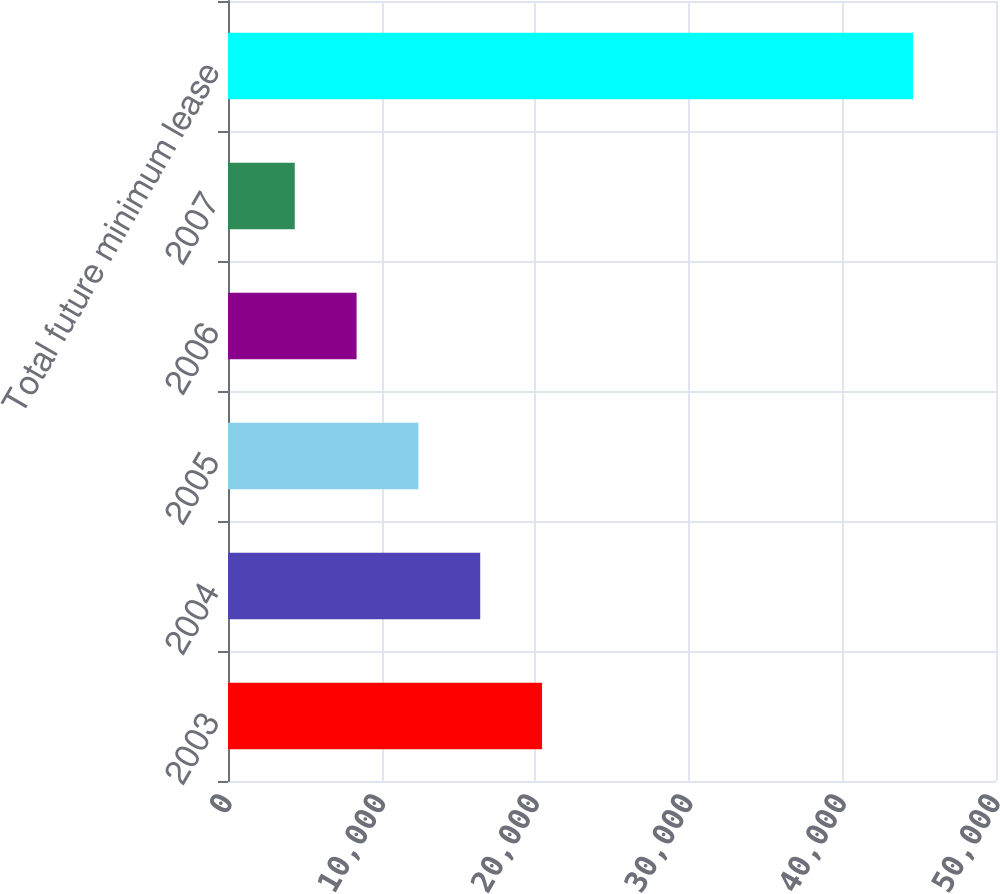Convert chart. <chart><loc_0><loc_0><loc_500><loc_500><bar_chart><fcel>2003<fcel>2004<fcel>2005<fcel>2006<fcel>2007<fcel>Total future minimum lease<nl><fcel>20446<fcel>16421<fcel>12396<fcel>8371<fcel>4346<fcel>44596<nl></chart> 